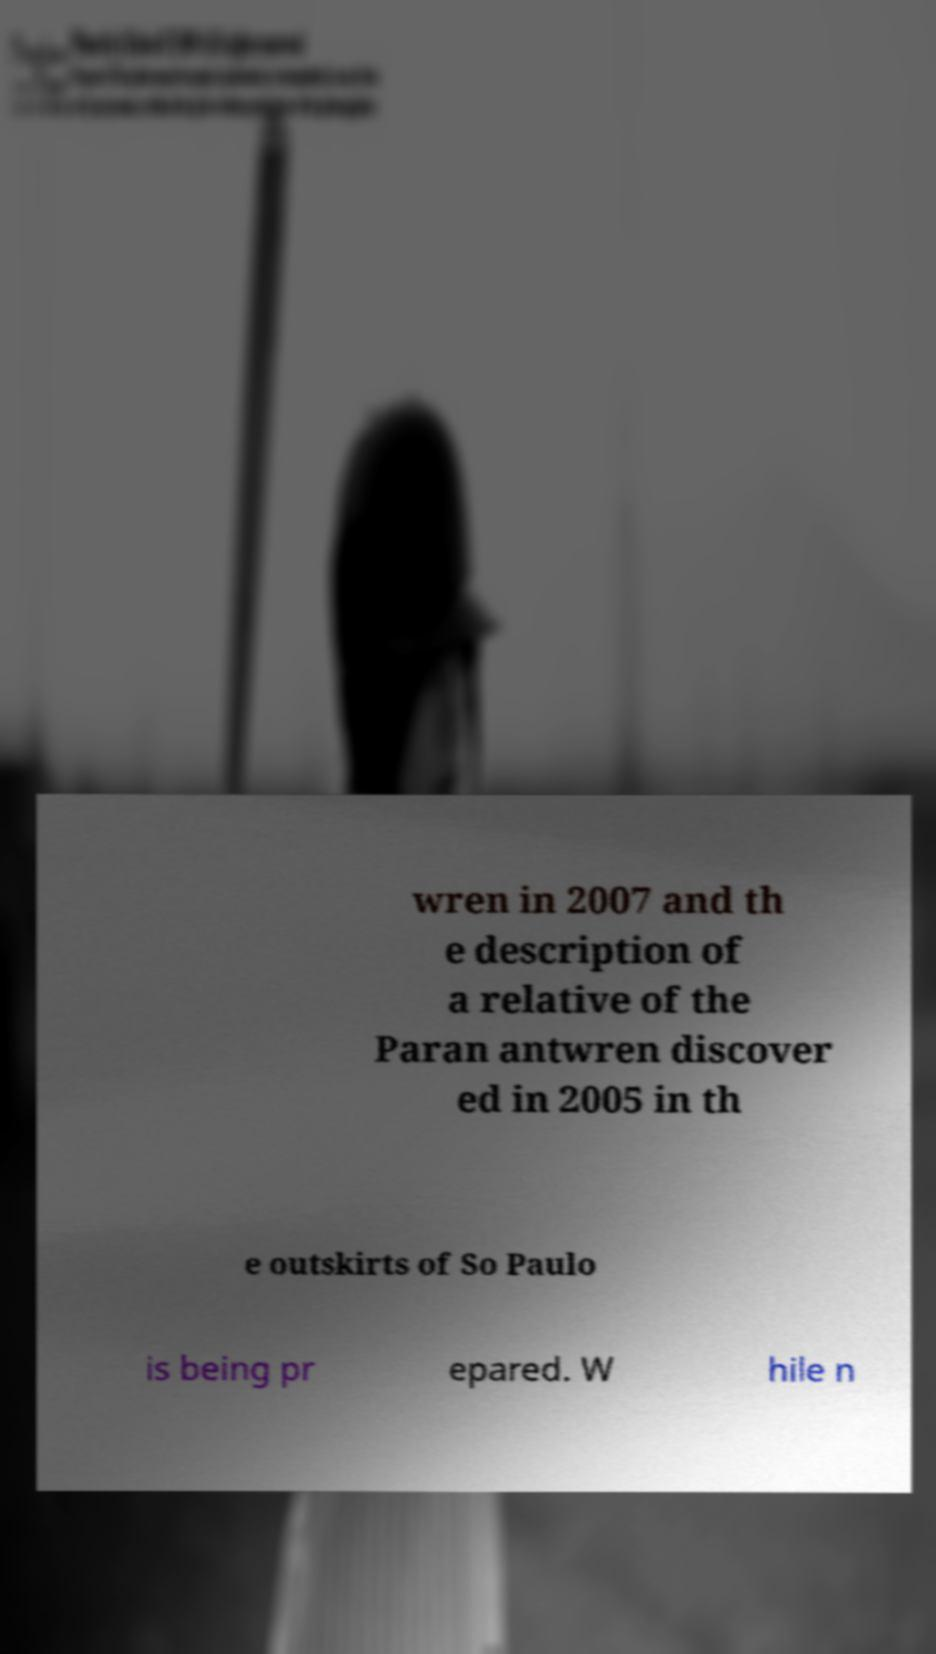Please identify and transcribe the text found in this image. wren in 2007 and th e description of a relative of the Paran antwren discover ed in 2005 in th e outskirts of So Paulo is being pr epared. W hile n 